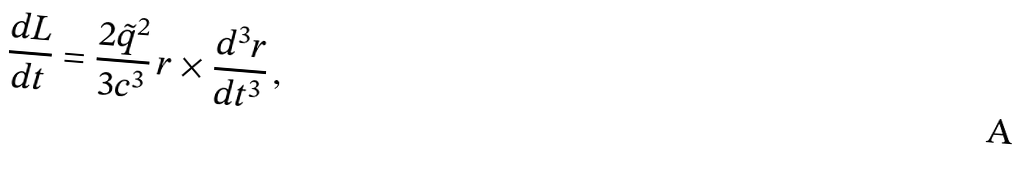Convert formula to latex. <formula><loc_0><loc_0><loc_500><loc_500>\frac { d { L } } { d t } = \frac { 2 \tilde { q } ^ { 2 } } { 3 c ^ { 3 } } \, { r } \times \frac { d ^ { 3 } { r } } { d t ^ { 3 } } \, ,</formula> 